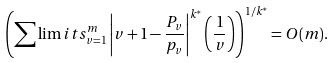Convert formula to latex. <formula><loc_0><loc_0><loc_500><loc_500>\left ( \sum \lim i t s _ { v = 1 } ^ { m } \left | v + 1 - \frac { P _ { v } } { p _ { v } } \right | ^ { k ^ { \ast } } \left ( \frac { 1 } { v } \right ) \right ) ^ { 1 / k ^ { \ast } } = O ( m ) .</formula> 